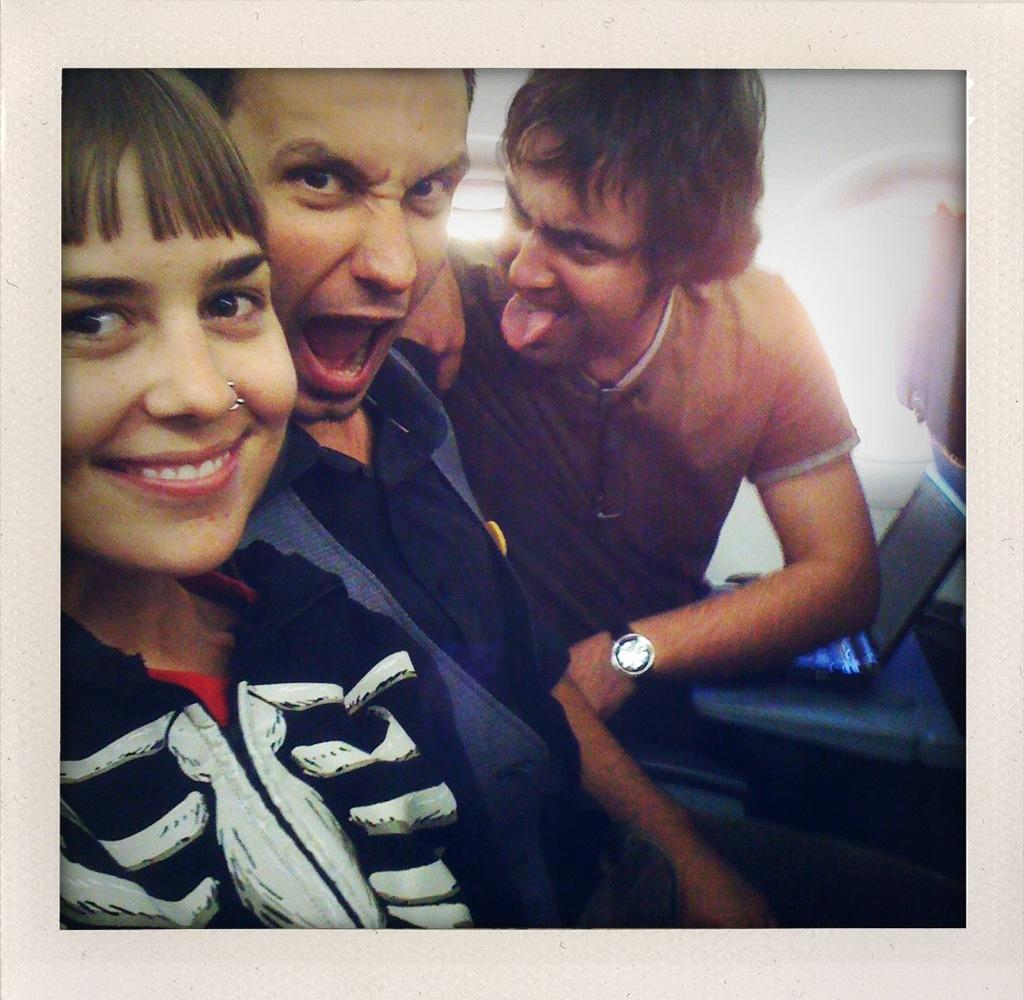How many people are in the image? There are three people in the image: two boys and a girl. What are the boys doing in the image? The boys are sitting on chairs, smiling, and giving a pose into the camera. What is the girl doing in the image? The girl is smiling and giving a pose. What type of orange wire can be seen connecting the boys in the image? There is no orange wire present in the image; it features two boys and a girl posing for a photo. 